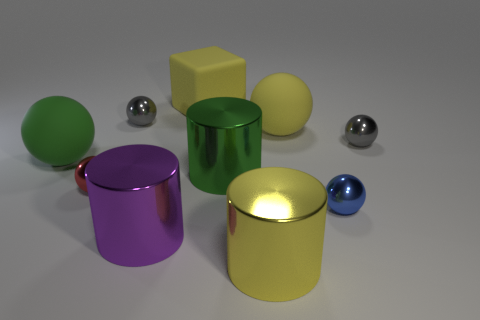Is the material of the big cylinder on the left side of the matte block the same as the yellow block?
Provide a succinct answer. No. There is a rubber ball that is on the right side of the big metal object that is behind the tiny blue sphere; are there any big matte objects in front of it?
Ensure brevity in your answer.  Yes. What number of cubes are large yellow rubber objects or tiny gray objects?
Provide a succinct answer. 1. What material is the big green object to the left of the yellow matte cube?
Keep it short and to the point. Rubber. There is a cylinder that is the same color as the matte cube; what size is it?
Make the answer very short. Large. There is a rubber cube behind the blue object; does it have the same color as the rubber thing on the right side of the green cylinder?
Keep it short and to the point. Yes. What number of objects are tiny red shiny things or metal objects?
Provide a succinct answer. 7. How many other things are the same shape as the blue object?
Ensure brevity in your answer.  5. Do the large green thing that is to the left of the big purple metallic thing and the tiny gray object to the left of the green cylinder have the same material?
Your response must be concise. No. There is a small metal object that is in front of the green sphere and behind the blue metal ball; what is its shape?
Your response must be concise. Sphere. 